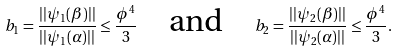<formula> <loc_0><loc_0><loc_500><loc_500>b _ { 1 } = \frac { | | \psi _ { 1 } ( \beta ) | | } { | | \psi _ { 1 } ( \alpha ) | | } \leq \frac { \phi ^ { 4 } } { 3 } \quad \text {and} \quad b _ { 2 } = \frac { | | \psi _ { 2 } ( \beta ) | | } { | | \psi _ { 2 } ( \alpha ) | | } \leq \frac { \phi ^ { 4 } } { 3 } .</formula> 